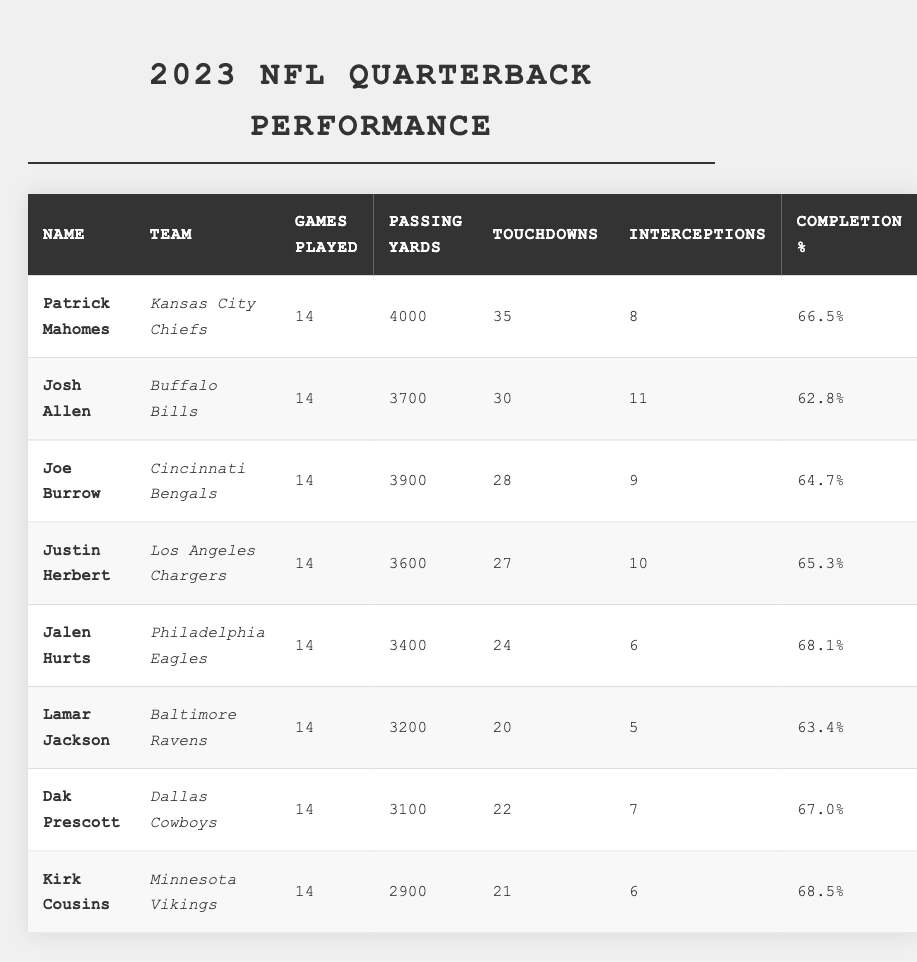What are the passing yards of Patrick Mahomes? The table shows that Patrick Mahomes has accumulated 4000 passing yards during the 2023 season.
Answer: 4000 Who has the highest number of touchdowns? By reviewing the touchdowns column, Patrick Mahomes leads with 35 touchdowns.
Answer: Patrick Mahomes How many interceptions did Jalen Hurts have? The table indicates that Jalen Hurts recorded 6 interceptions in the current season.
Answer: 6 Which quarterback has the lowest completion percentage? Looking at the completion percentage column, Josh Allen has the lowest at 62.8%.
Answer: Josh Allen What is the sum of touchdowns for Joe Burrow and Dak Prescott? Joe Burrow has 28 touchdowns, and Dak Prescott has 22. The sum is 28 + 22 = 50.
Answer: 50 Who has the highest completion percentage among the quarterbacks? The completion percentage column shows that Jalen Hurts has the highest percentage at 68.1%.
Answer: Jalen Hurts Calculate the average passing yards of the quarterbacks listed. Adding the passing yards (4000 + 3700 + 3900 + 3600 + 3400 + 3200 + 3100 + 2900 =  30500) and dividing by the number of quarterbacks (8), we get 30500 / 8 = 3812.5.
Answer: 3812.5 Is it true that Lamar Jackson has more interceptions than Jalen Hurts? Comparing their interceptions, Lamar Jackson has 5 and Jalen Hurts has 6, which means Jackson has fewer. Therefore, the statement is false.
Answer: No Who has the most passing yards among the quarterbacks from the table? Reviewing the passing yards, Patrick Mahomes has the most at 4000 yards.
Answer: Patrick Mahomes What are the total games played by all quarterbacks combined? All quarterbacks played 14 games each: 14 * 8 = 112 games played in total.
Answer: 112 